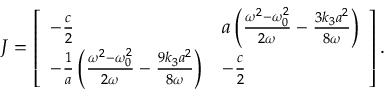<formula> <loc_0><loc_0><loc_500><loc_500>\boldsymbol J = \left [ \begin{array} { l l } { - \frac { c } { 2 } } & { a \left ( \frac { \omega ^ { 2 } - \omega _ { 0 } ^ { 2 } } { 2 \omega } - \frac { 3 k _ { 3 } a ^ { 2 } } { 8 \omega } \right ) } \\ { - \frac { 1 } { a } \left ( \frac { \omega ^ { 2 } - \omega _ { 0 } ^ { 2 } } { 2 \omega } - \frac { 9 k _ { 3 } a ^ { 2 } } { 8 \omega } \right ) } & { - \frac { c } { 2 } } \end{array} \right ] .</formula> 